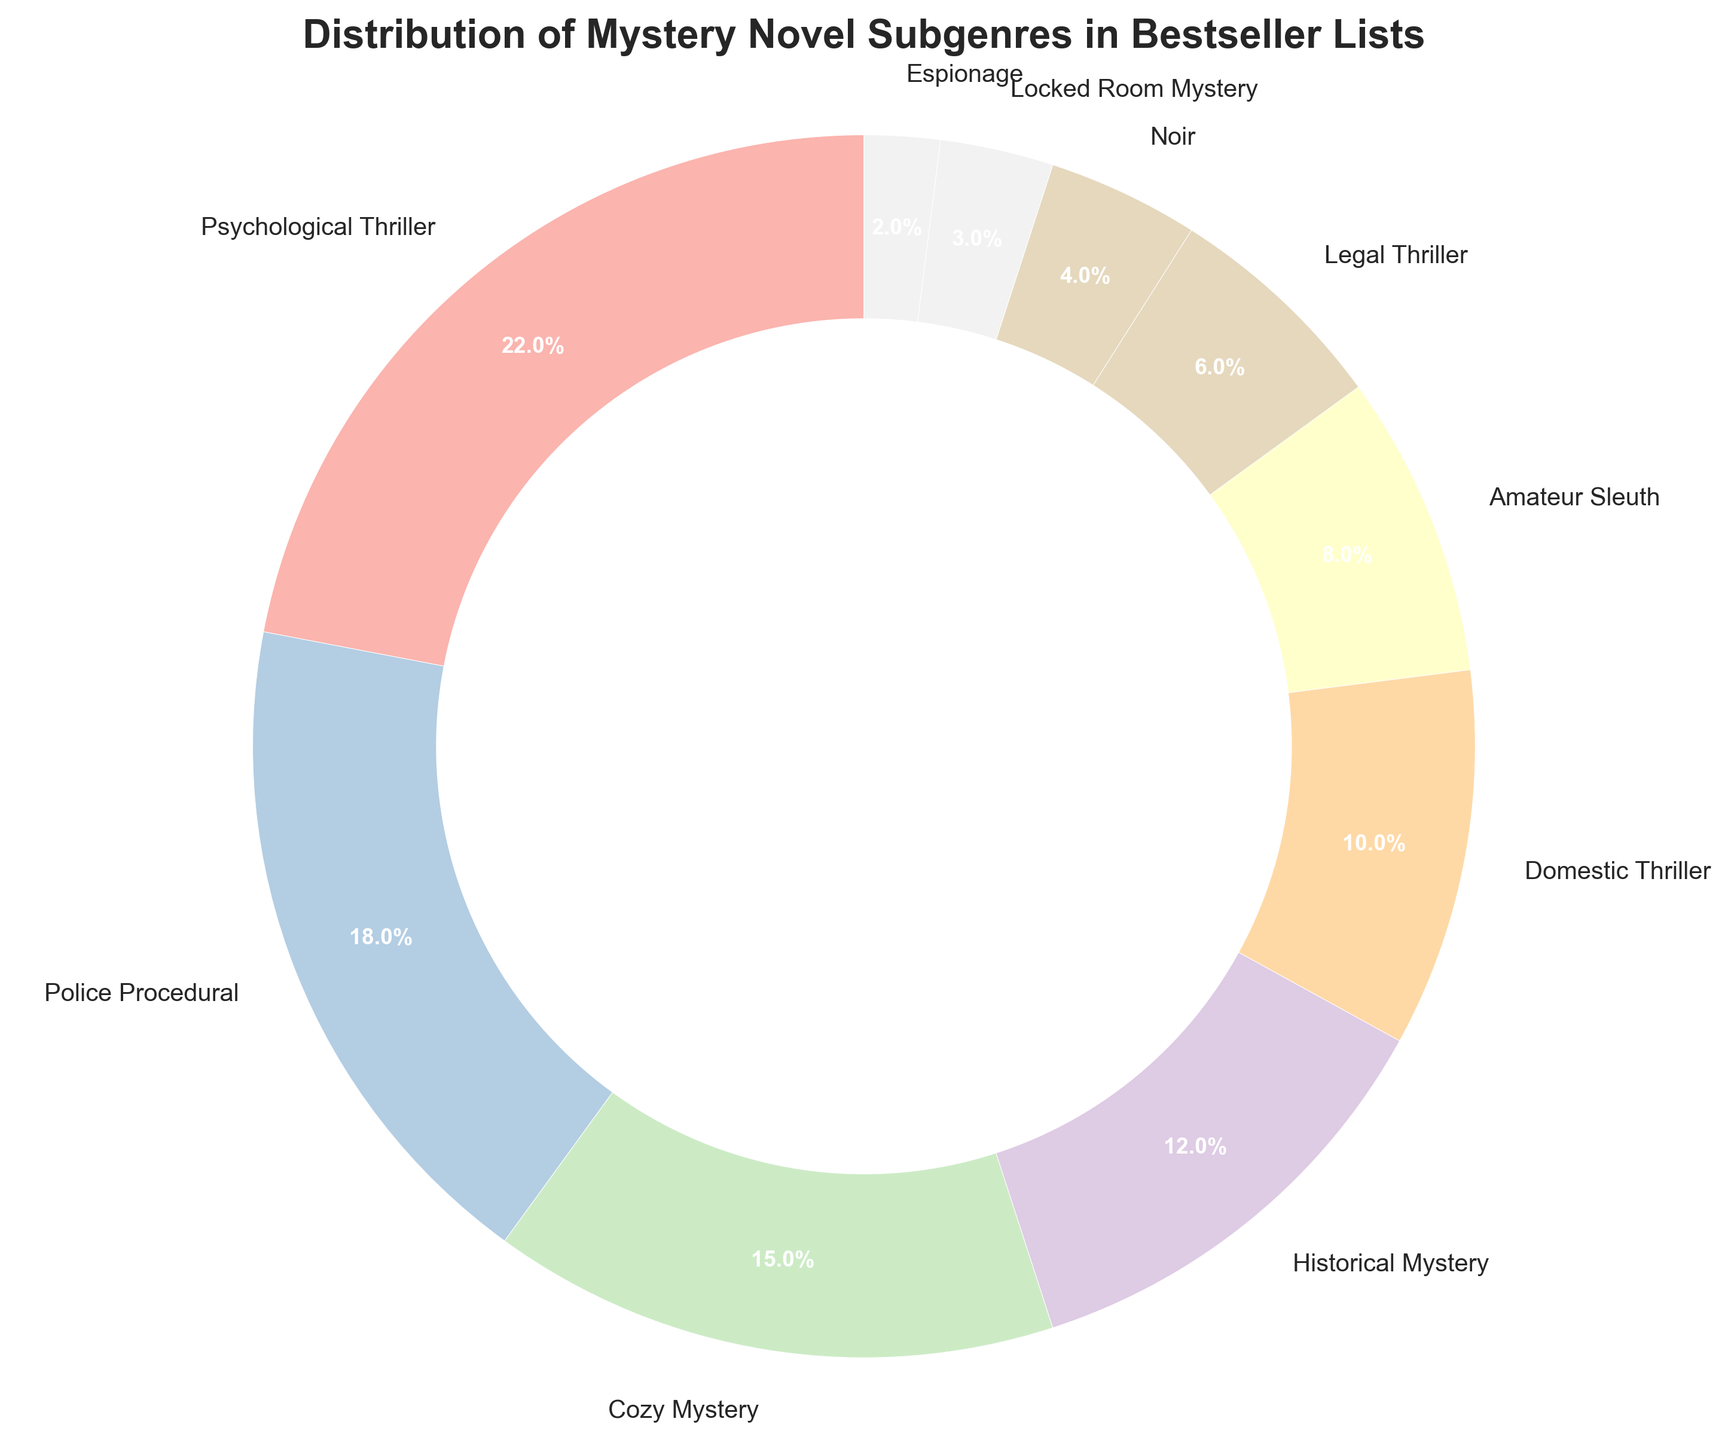What is the most popular subgenre? The most popular subgenre is the one with the highest percentage in the pie chart. The 'Psychological Thriller' has the largest section with 22%.
Answer: Psychological Thriller Which subgenres have a percentage greater than 15%? To find the subgenres with a percentage greater than 15%, look for sections larger than 15% in the pie chart. 'Psychological Thriller' (22%) and 'Police Procedural' (18%) fit this criterion.
Answer: Psychological Thriller, Police Procedural What is the combined percentage of 'Cozy Mystery' and 'Historical Mystery'? Add the percentages of 'Cozy Mystery' (15%) and 'Historical Mystery' (12%). 15 + 12 = 27%
Answer: 27% Is the 'Noir' subgenre more common than 'Locked Room Mystery'? Compare the percentages of 'Noir' (4%) and 'Locked Room Mystery' (3%). 4% is greater than 3%, so 'Noir' is more common.
Answer: Yes Which subgenre has the least representation in the chart? The least represented subgenre is the smallest section in the pie chart. 'Espionage' has the smallest portion with 2%.
Answer: Espionage What is the difference in percentage between 'Police Procedural' and 'Domestic Thriller'? Subtract the percentage of 'Domestic Thriller' (10%) from 'Police Procedural' (18%). 18 - 10 = 8%
Answer: 8% When you combine 'Legal Thriller' and 'Noir', is their total percentage more than 'Cozy Mystery' alone? Add the percentages of 'Legal Thriller' (6%) and 'Noir' (4%). 6 + 4 = 10%. Compare this with 'Cozy Mystery' (15%). 10% is not greater than 15%.
Answer: No What percentage of the chart does not belong to the top three subgenres (Psychological Thriller, Police Procedural, Cozy Mystery)? Sum the percentages of the top three subgenres: 22% (Psychological Thriller) + 18% (Police Procedural) + 15% (Cozy Mystery) = 55%. Subtract this from 100% to find the percentage that does not belong to these subgenres. 100 - 55 = 45%
Answer: 45% Which subgenre's percentage is closest to the average percentage of all subgenres? First, find the average percentage by adding all subgenre percentages and dividing by the number of subgenres. Total percentage is 100%, and there are 10 subgenres, so the average is 100 / 10 = 10%. 'Domestic Thriller' matches this average with exactly 10%.
Answer: Domestic Thriller 